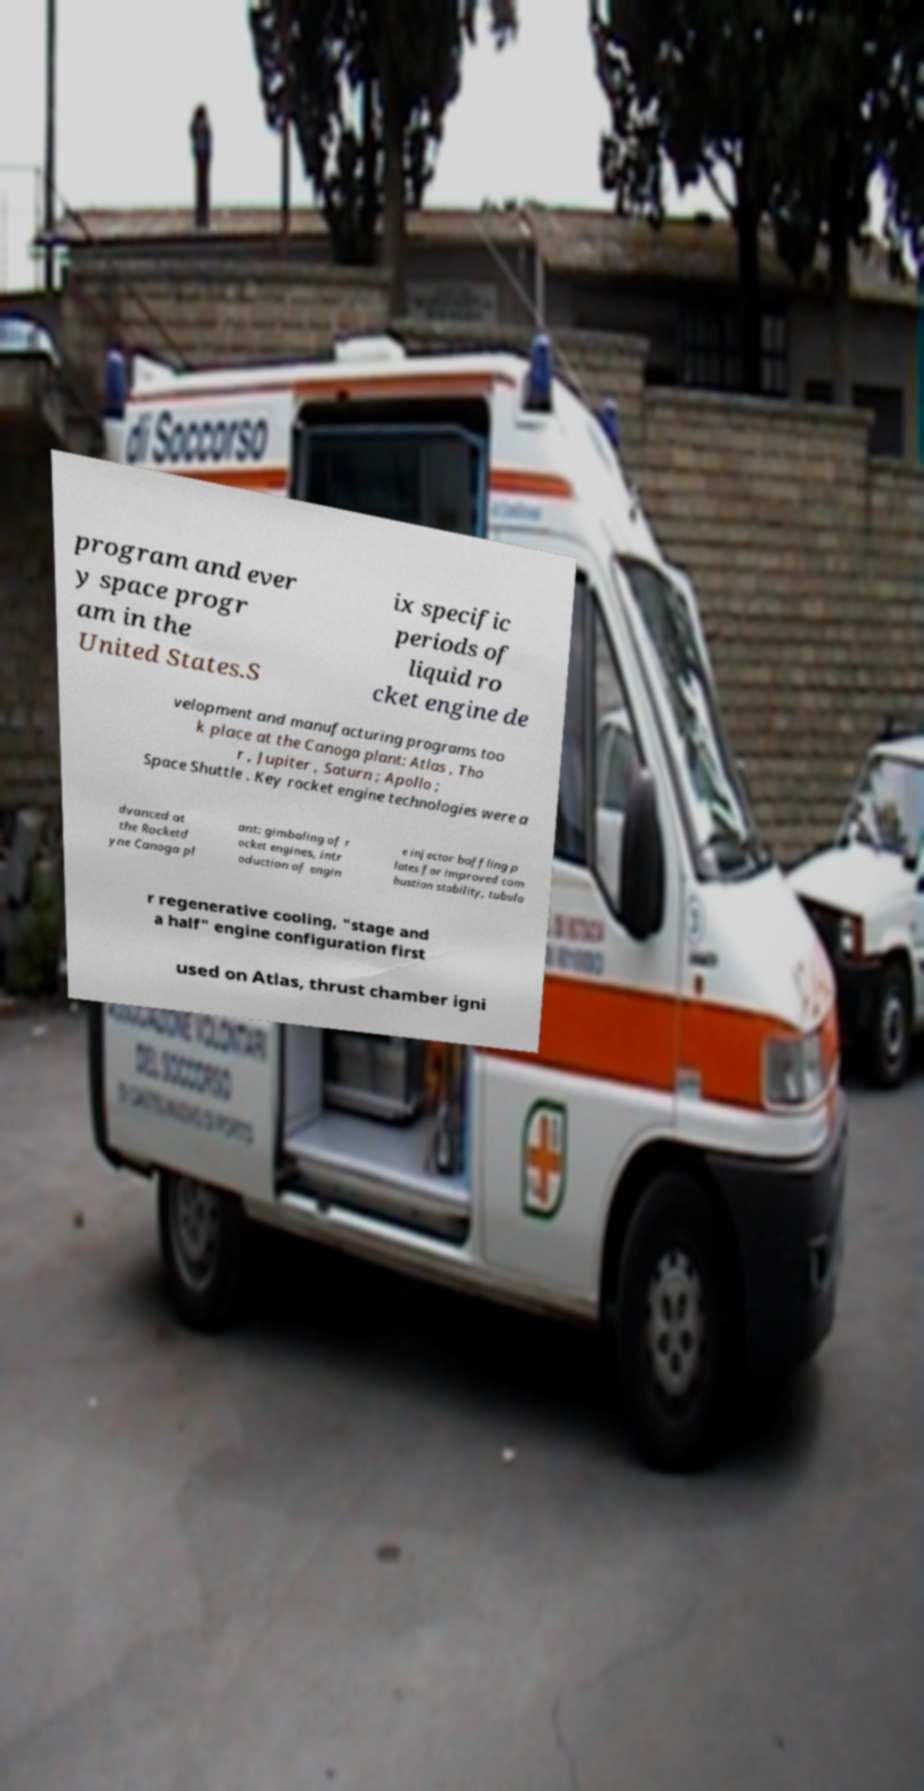Can you accurately transcribe the text from the provided image for me? program and ever y space progr am in the United States.S ix specific periods of liquid ro cket engine de velopment and manufacturing programs too k place at the Canoga plant: Atlas , Tho r , Jupiter , Saturn ; Apollo ; Space Shuttle . Key rocket engine technologies were a dvanced at the Rocketd yne Canoga pl ant: gimbaling of r ocket engines, intr oduction of engin e injector baffling p lates for improved com bustion stability, tubula r regenerative cooling, "stage and a half" engine configuration first used on Atlas, thrust chamber igni 